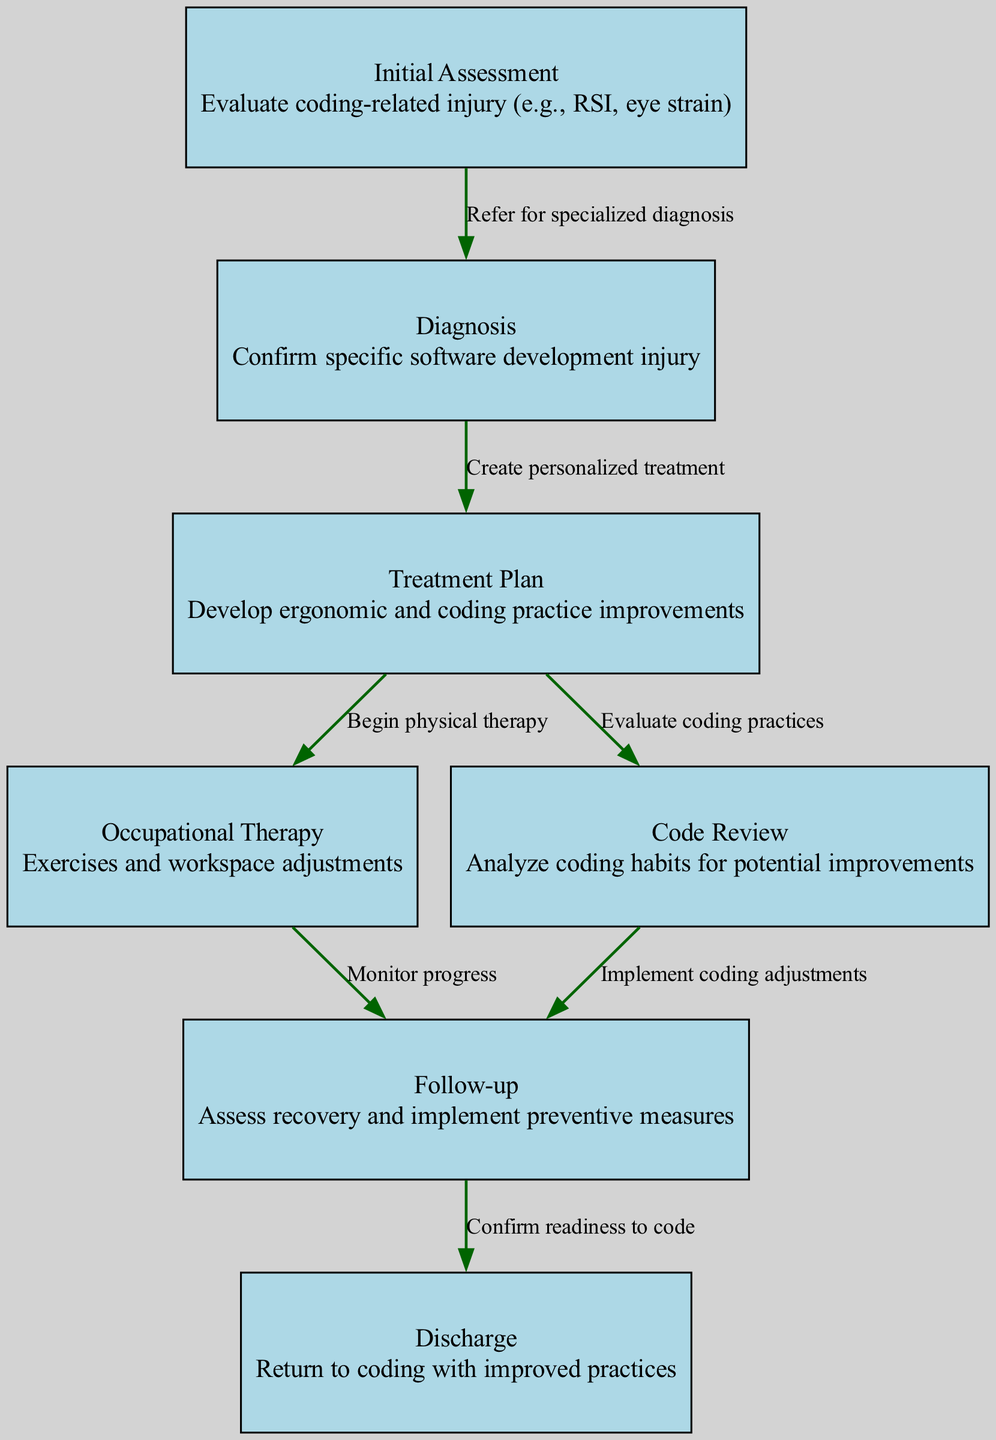What is the first step in the clinical pathway? The first step is listed as "Initial Assessment", where the evaluation of the coding-related injury begins.
Answer: Initial Assessment How many nodes are present in the diagram? By counting all the unique nodes in the diagram, we identify seven nodes in total.
Answer: 7 What comes after "Diagnosis" in the process? Following "Diagnosis", the next step in the diagram is "Treatment Plan", indicating what actions will follow the diagnosis.
Answer: Treatment Plan Which nodes lead to "Follow-up"? The "Follow-up" node is connected from both "Occupational Therapy" and "Code Review", showing the paths that lead to this step in recovery.
Answer: Occupational Therapy, Code Review What is the label of the node connected to "Treatment Plan"? The node connected to "Treatment Plan" is "Occupational Therapy" and "Code Review". Both nodes have direct relationships with the "Treatment Plan" node.
Answer: Occupational Therapy, Code Review How many edges are there in total? Counting all the directed edges that show the relationships and paths between the nodes gives a total of six edges in this clinical pathway.
Answer: 6 What is the final step before "Discharge"? The step immediately preceding "Discharge" is "Follow-up". The diagram shows that the follow-up process is the last phase before discharge.
Answer: Follow-up Which node is described as having exercises and workspace adjustments? The node that describes exercises and workspace adjustments is "Occupational Therapy", indicating the focus on rehabilitation in the process.
Answer: Occupational Therapy What action is taken during the "Initial Assessment"? During the "Initial Assessment", the main action is to evaluate the coding-related injury, which is a critical first step in understanding the patient's needs.
Answer: Evaluate coding-related injury 